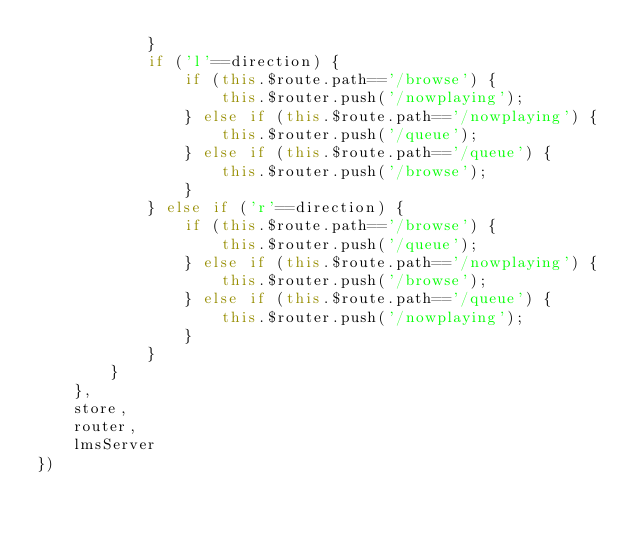<code> <loc_0><loc_0><loc_500><loc_500><_JavaScript_>            }
            if ('l'==direction) {
                if (this.$route.path=='/browse') {
                    this.$router.push('/nowplaying');
                } else if (this.$route.path=='/nowplaying') {
                    this.$router.push('/queue');
                } else if (this.$route.path=='/queue') {
                    this.$router.push('/browse');
                }
            } else if ('r'==direction) {
                if (this.$route.path=='/browse') {
                    this.$router.push('/queue');
                } else if (this.$route.path=='/nowplaying') {
                    this.$router.push('/browse');
                } else if (this.$route.path=='/queue') {
                    this.$router.push('/nowplaying');
                }
            }
        }
    },
    store,
    router,
    lmsServer
})

</code> 